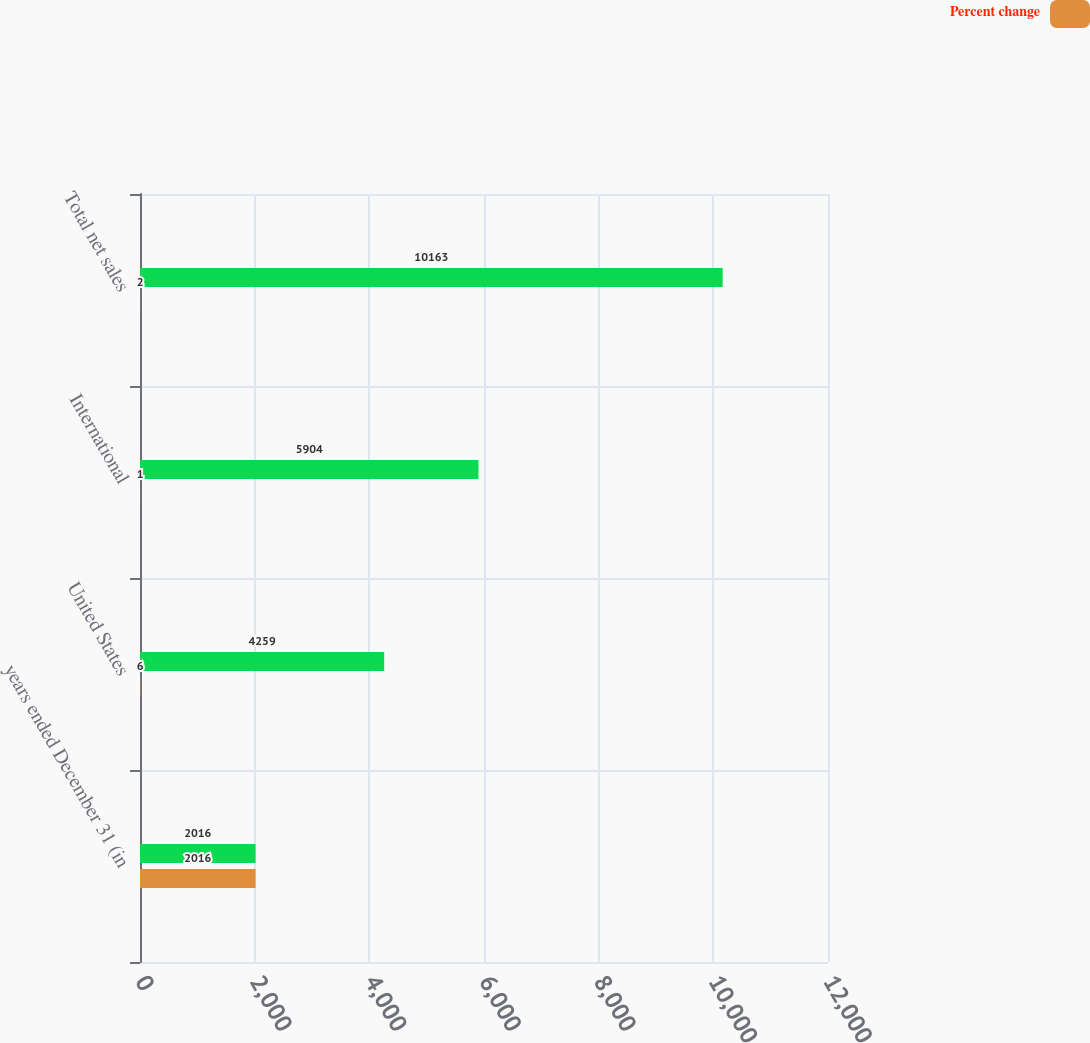Convert chart. <chart><loc_0><loc_0><loc_500><loc_500><stacked_bar_chart><ecel><fcel>years ended December 31 (in<fcel>United States<fcel>International<fcel>Total net sales<nl><fcel>nan<fcel>2016<fcel>4259<fcel>5904<fcel>10163<nl><fcel>Percent change<fcel>2016<fcel>6<fcel>1<fcel>2<nl></chart> 